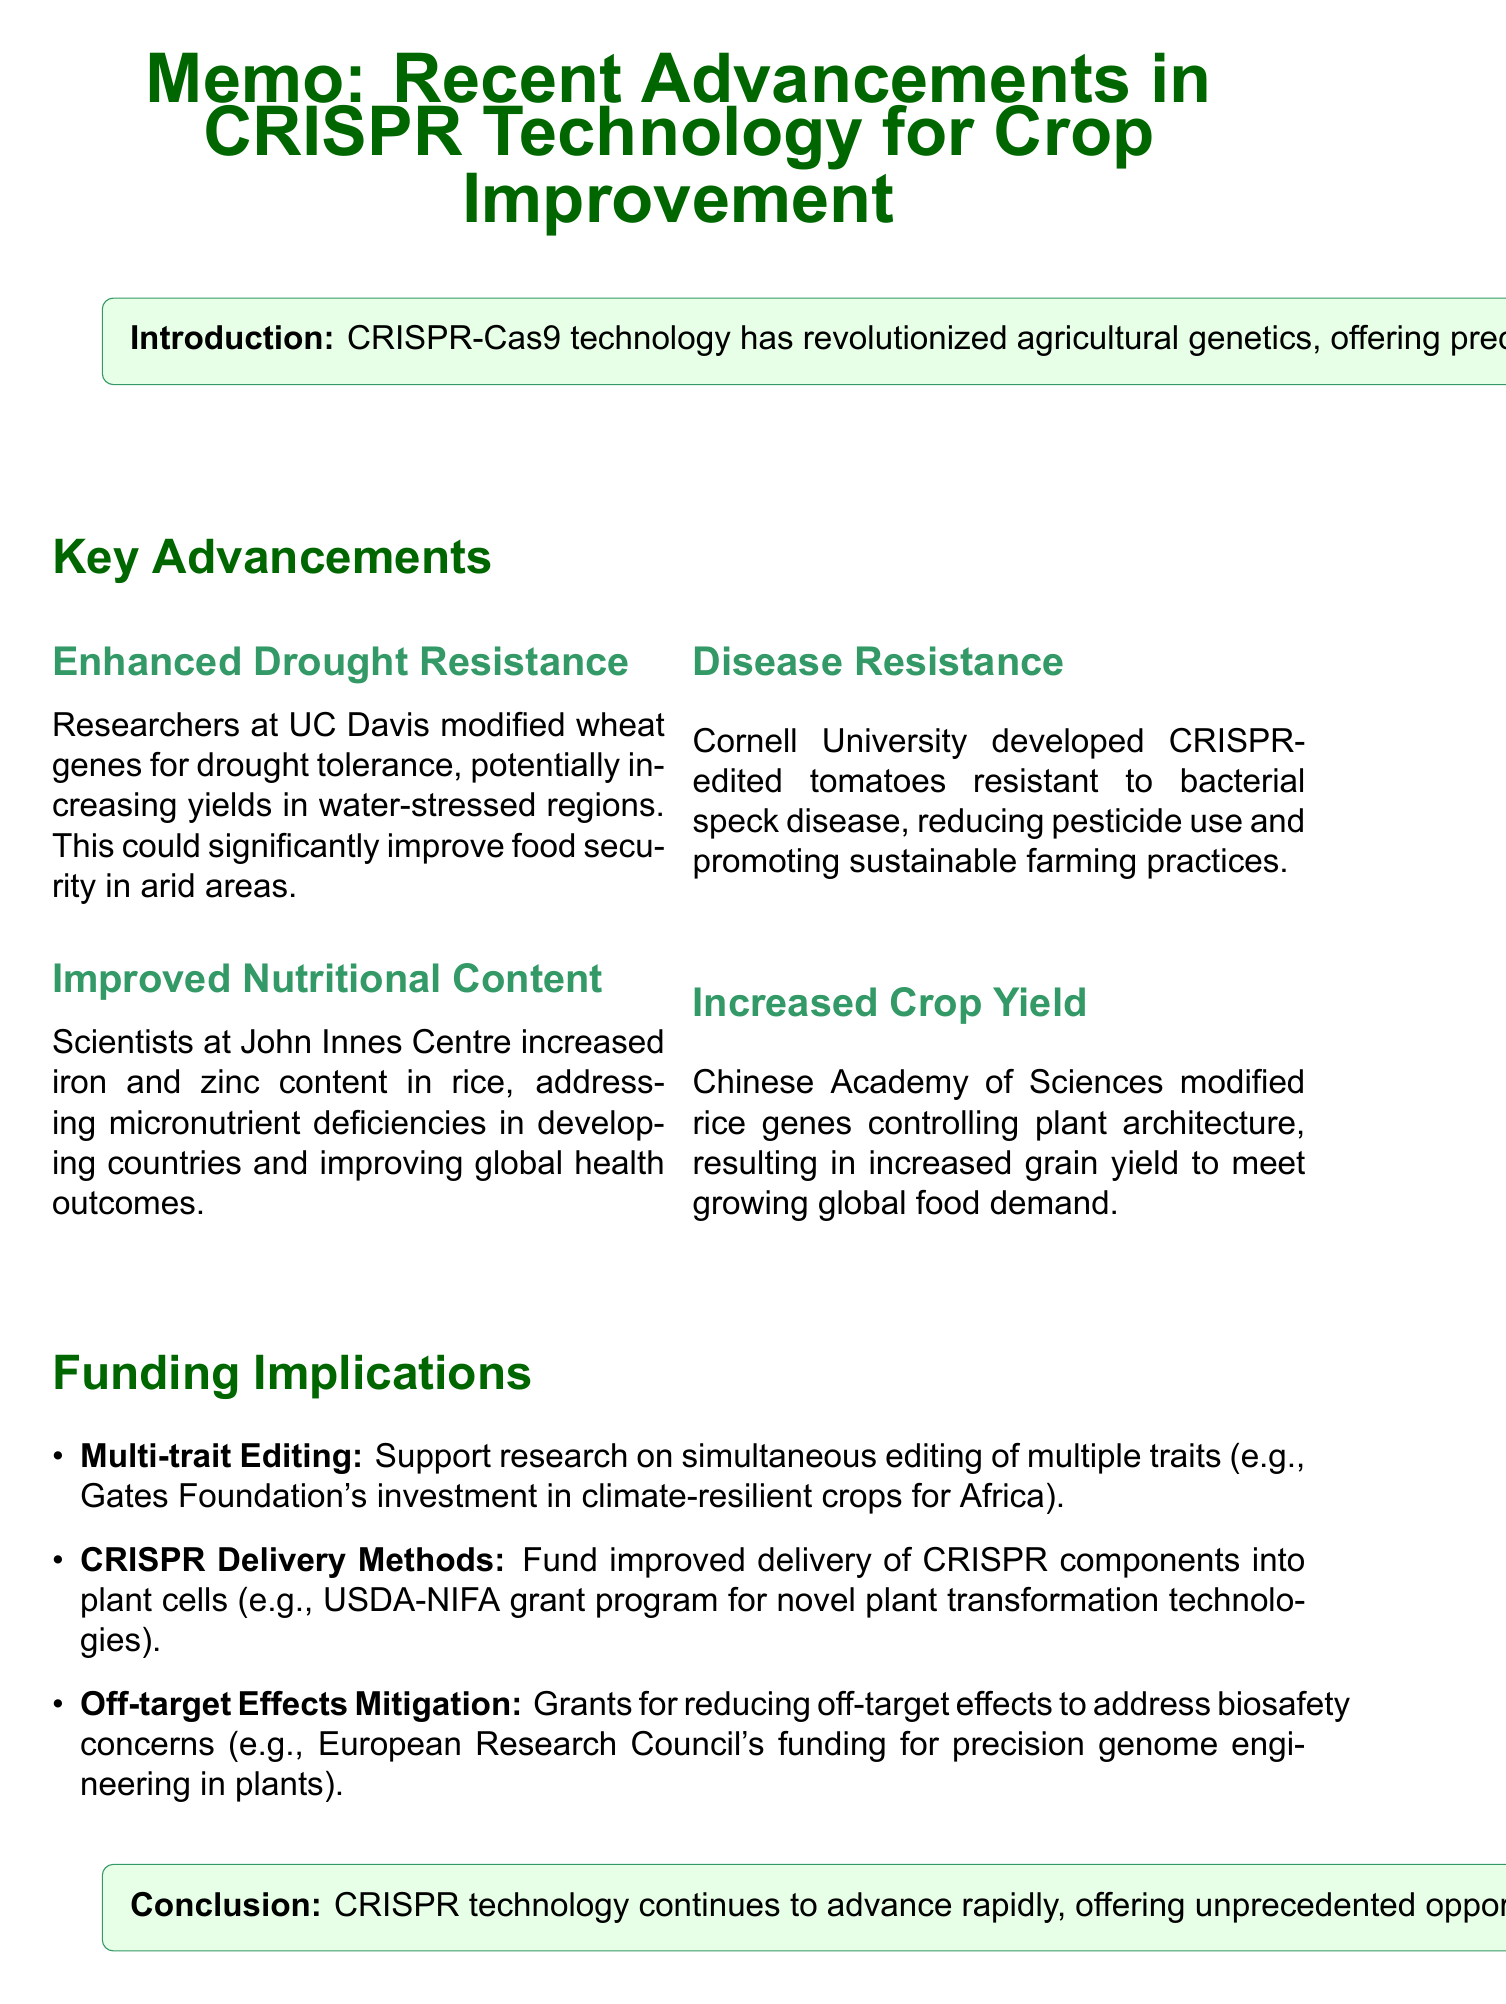what technology has revolutionized agricultural genetics? The document states that CRISPR-Cas9 technology has revolutionized agricultural genetics.
Answer: CRISPR-Cas9 which university modified wheat genes for drought tolerance? The document specifies that researchers at the University of California, Davis modified wheat genes for drought tolerance.
Answer: University of California, Davis what diseases are CRISPR-edited tomatoes resistant to? The memo mentions that the CRISPR-edited tomatoes are resistant to bacterial speck disease.
Answer: bacterial speck disease which organization invested in climate-resilient crops research? The document gives an example of the Bill & Melinda Gates Foundation investing in CRISPR research for climate-resilient crops.
Answer: Bill & Melinda Gates Foundation what trait was improved in rice by scientists at the John Innes Centre? The document describes that scientists increased iron and zinc content in rice to address deficiencies.
Answer: iron and zinc content what is a potential benefit of enhanced drought resistance in crops? The impact of enhanced drought resistance mentioned in the memo is to significantly improve food security in arid areas.
Answer: significantly improve food security how many key advancements in CRISPR technology for crop improvement are listed? The document lists a total of four key advancements in CRISPR technology for crop improvement.
Answer: four what is the focus of funding for CRISPR delivery methods? The document states that funding aims to improve delivery methods of CRISPR components into plant cells.
Answer: improve delivery methods what should be prioritized according to the conclusion of the memo? The memo's conclusion recommends prioritizing funding for innovative CRISPR research projects that address agricultural challenges.
Answer: funding for innovative CRISPR research projects 